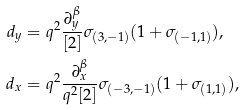Convert formula to latex. <formula><loc_0><loc_0><loc_500><loc_500>d _ { y } & = q ^ { 2 } \frac { \partial _ { y } ^ { \beta } } { [ 2 ] } \sigma _ { ( 3 , - 1 ) } ( 1 + \sigma _ { ( - 1 , 1 ) } ) , \\ d _ { x } & = q ^ { 2 } \frac { \partial _ { x } ^ { \beta } } { q ^ { 2 } [ 2 ] } \sigma _ { ( - 3 , - 1 ) } ( 1 + \sigma _ { ( 1 , 1 ) } ) ,</formula> 